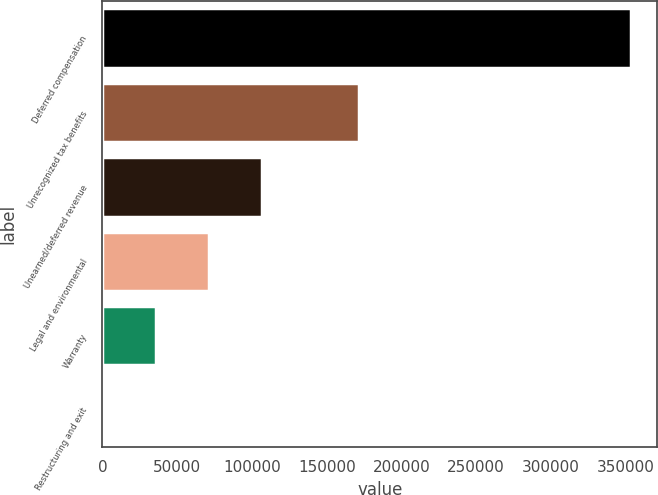Convert chart to OTSL. <chart><loc_0><loc_0><loc_500><loc_500><bar_chart><fcel>Deferred compensation<fcel>Unrecognized tax benefits<fcel>Unearned/deferred revenue<fcel>Legal and environmental<fcel>Warranty<fcel>Restructuring and exit<nl><fcel>353509<fcel>171551<fcel>106455<fcel>71161.8<fcel>35868.4<fcel>575<nl></chart> 